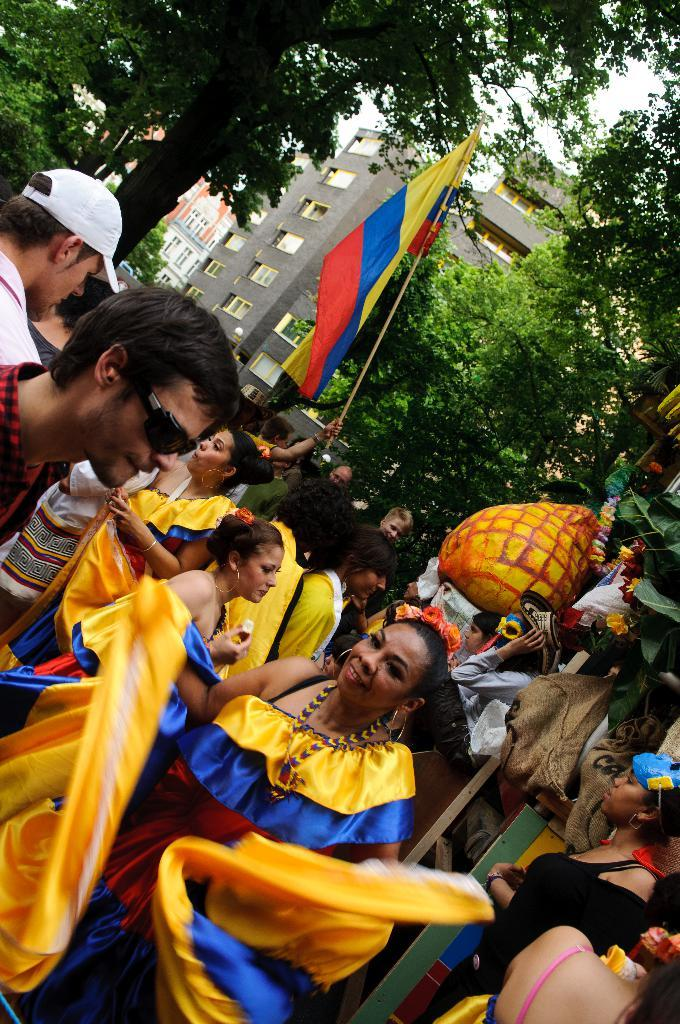What are the people at the bottom of the image doing? The people at the bottom of the image are holding a flag. What can be seen at the top of the image? There are trees and buildings at the top of the image. What type of juice can be seen flowing through the quicksand in the image? There is no juice or quicksand present in the image. 